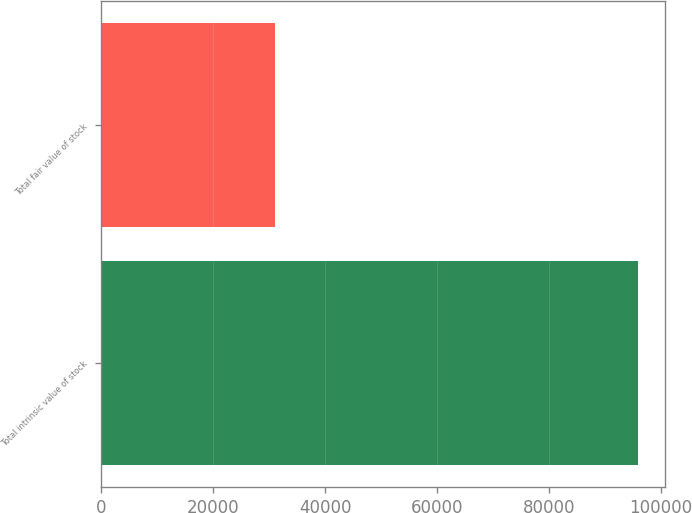Convert chart to OTSL. <chart><loc_0><loc_0><loc_500><loc_500><bar_chart><fcel>Total intrinsic value of stock<fcel>Total fair value of stock<nl><fcel>95891<fcel>30964<nl></chart> 